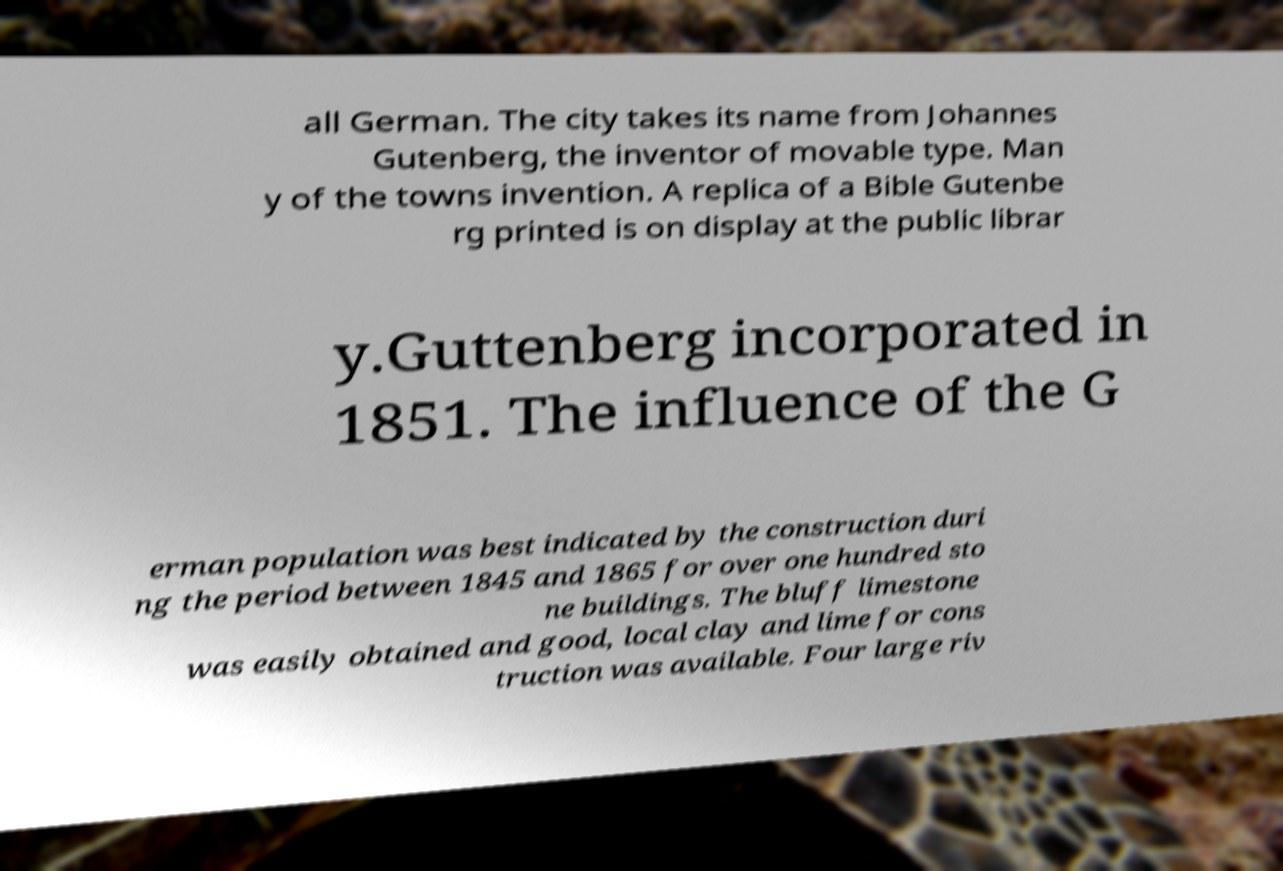I need the written content from this picture converted into text. Can you do that? all German. The city takes its name from Johannes Gutenberg, the inventor of movable type. Man y of the towns invention. A replica of a Bible Gutenbe rg printed is on display at the public librar y.Guttenberg incorporated in 1851. The influence of the G erman population was best indicated by the construction duri ng the period between 1845 and 1865 for over one hundred sto ne buildings. The bluff limestone was easily obtained and good, local clay and lime for cons truction was available. Four large riv 